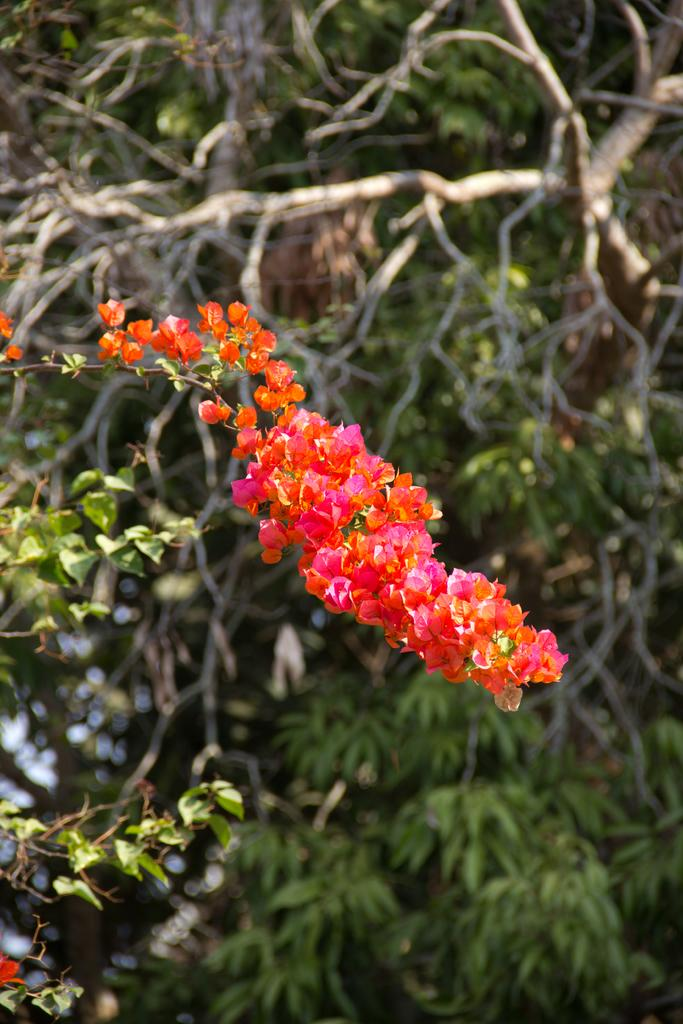What type of plant can be seen in the image? There is a flower in the image. What other plant is visible in the image? There is a tree in the image. What part of the plants can be seen in the image? There are leaves in the image. What is the price of the farmer's hat in the image? There is no farmer or hat present in the image. 